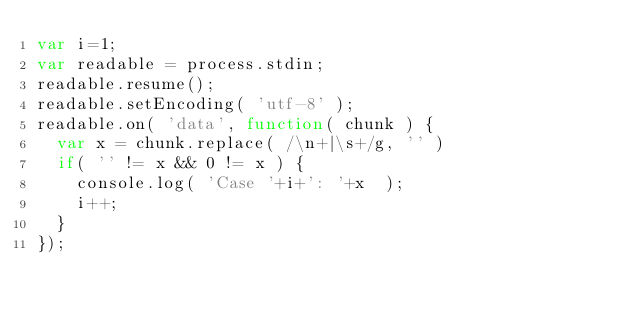Convert code to text. <code><loc_0><loc_0><loc_500><loc_500><_JavaScript_>var i=1;
var readable = process.stdin;
readable.resume();
readable.setEncoding( 'utf-8' );
readable.on( 'data', function( chunk ) {
  var x = chunk.replace( /\n+|\s+/g, '' )
  if( '' != x && 0 != x ) {
    console.log( 'Case '+i+': '+x  );
    i++;
  }
});</code> 